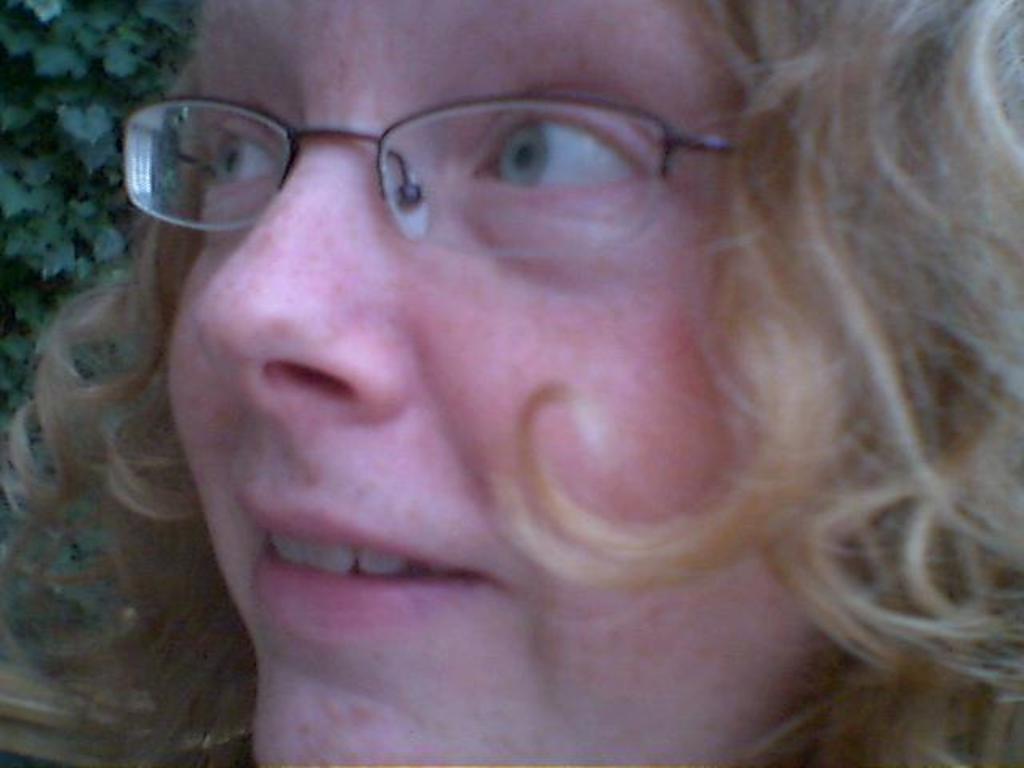Could you give a brief overview of what you see in this image? In this picture we can observe a woman wearing spectacles. We can observe cream color hair. In a background there are some leaves. 